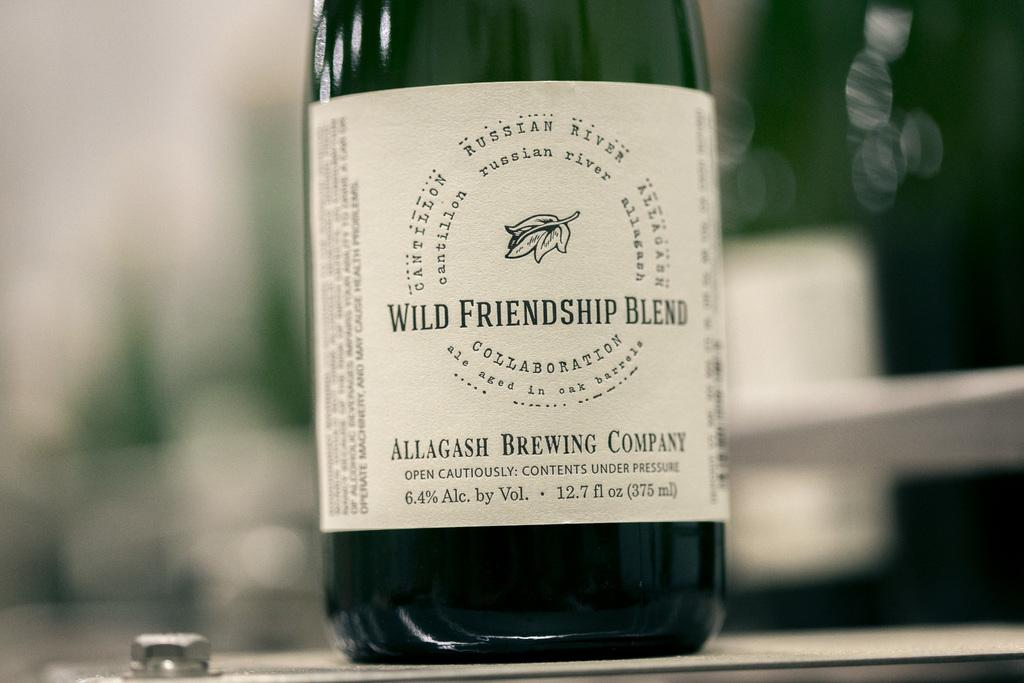<image>
Relay a brief, clear account of the picture shown. Green bottle with a white label that says "Wild Friendship Blend" on it. 